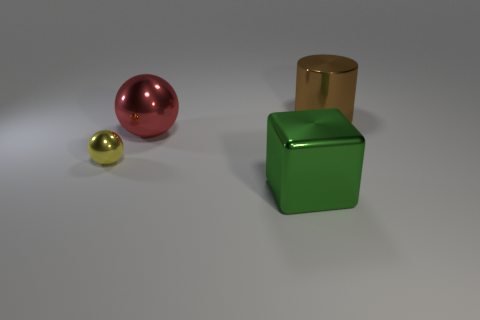Add 1 large red metallic blocks. How many objects exist? 5 Subtract all cubes. How many objects are left? 3 Add 2 large red things. How many large red things are left? 3 Add 1 brown cylinders. How many brown cylinders exist? 2 Subtract 0 gray cylinders. How many objects are left? 4 Subtract all yellow metal things. Subtract all large objects. How many objects are left? 0 